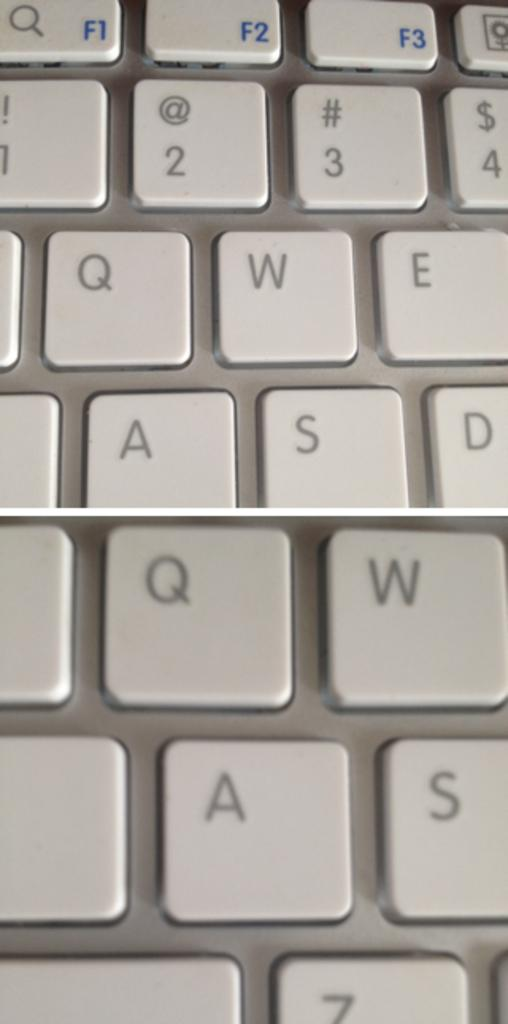Provide a one-sentence caption for the provided image. The top middle blue button is the key for F3. 